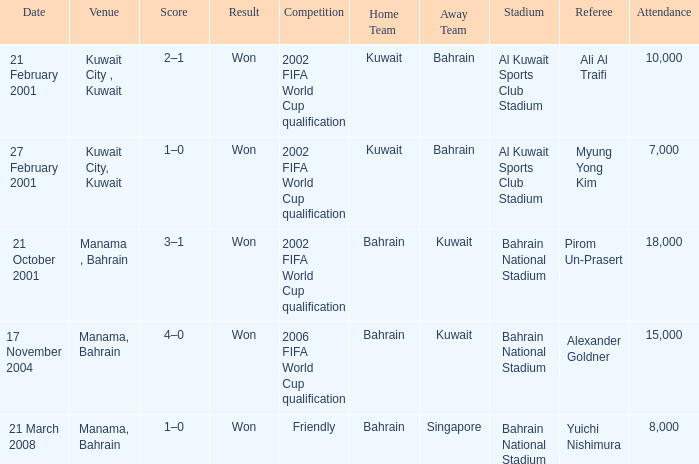What was the final score of the Friendly Competition in Manama, Bahrain? 1–0. 